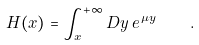<formula> <loc_0><loc_0><loc_500><loc_500>H ( x ) = \int _ { x } ^ { + \infty } D y \, e ^ { \, \mu y } \quad .</formula> 